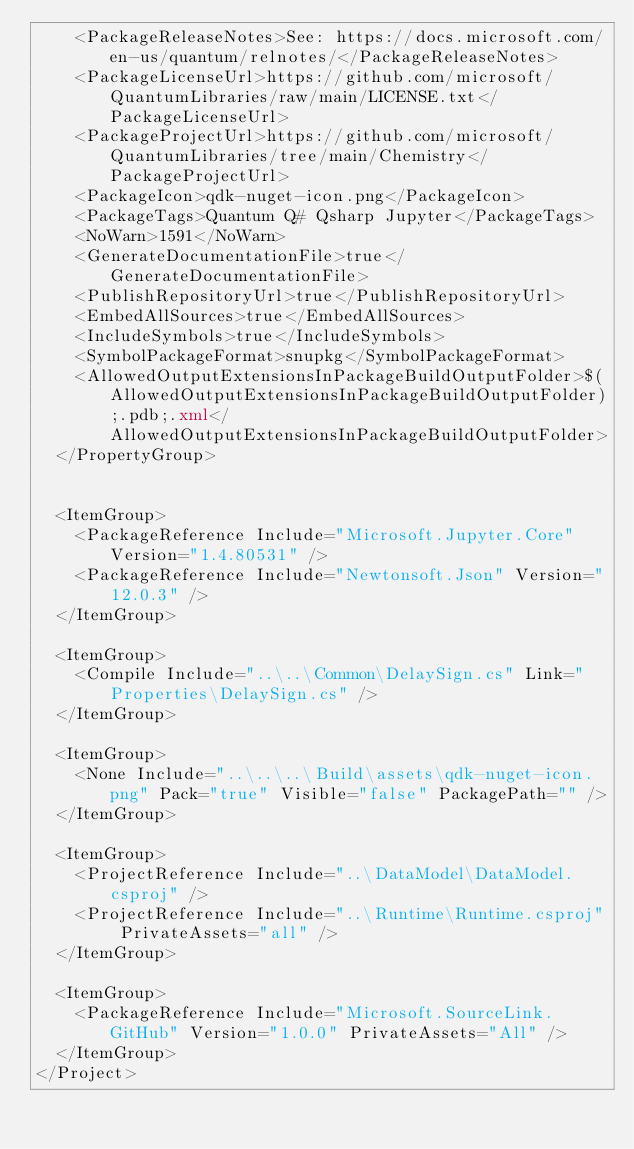Convert code to text. <code><loc_0><loc_0><loc_500><loc_500><_XML_>    <PackageReleaseNotes>See: https://docs.microsoft.com/en-us/quantum/relnotes/</PackageReleaseNotes>
    <PackageLicenseUrl>https://github.com/microsoft/QuantumLibraries/raw/main/LICENSE.txt</PackageLicenseUrl>
    <PackageProjectUrl>https://github.com/microsoft/QuantumLibraries/tree/main/Chemistry</PackageProjectUrl>
    <PackageIcon>qdk-nuget-icon.png</PackageIcon>
    <PackageTags>Quantum Q# Qsharp Jupyter</PackageTags>
    <NoWarn>1591</NoWarn>
    <GenerateDocumentationFile>true</GenerateDocumentationFile>
    <PublishRepositoryUrl>true</PublishRepositoryUrl>
    <EmbedAllSources>true</EmbedAllSources>
    <IncludeSymbols>true</IncludeSymbols>
    <SymbolPackageFormat>snupkg</SymbolPackageFormat>
    <AllowedOutputExtensionsInPackageBuildOutputFolder>$(AllowedOutputExtensionsInPackageBuildOutputFolder);.pdb;.xml</AllowedOutputExtensionsInPackageBuildOutputFolder>
  </PropertyGroup>


  <ItemGroup>
    <PackageReference Include="Microsoft.Jupyter.Core" Version="1.4.80531" />
    <PackageReference Include="Newtonsoft.Json" Version="12.0.3" />
  </ItemGroup>

  <ItemGroup>
    <Compile Include="..\..\Common\DelaySign.cs" Link="Properties\DelaySign.cs" />
  </ItemGroup>

  <ItemGroup>
    <None Include="..\..\..\Build\assets\qdk-nuget-icon.png" Pack="true" Visible="false" PackagePath="" />
  </ItemGroup>

  <ItemGroup>
    <ProjectReference Include="..\DataModel\DataModel.csproj" />
    <ProjectReference Include="..\Runtime\Runtime.csproj" PrivateAssets="all" />
  </ItemGroup>

  <ItemGroup>
    <PackageReference Include="Microsoft.SourceLink.GitHub" Version="1.0.0" PrivateAssets="All" />
  </ItemGroup>
</Project>
</code> 